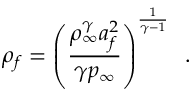<formula> <loc_0><loc_0><loc_500><loc_500>\rho _ { f } = \left ( \frac { \rho _ { \infty } ^ { \gamma } a _ { f } ^ { 2 } } { \gamma p _ { \infty } } \right ) ^ { \frac { 1 } { \gamma - 1 } } \, .</formula> 